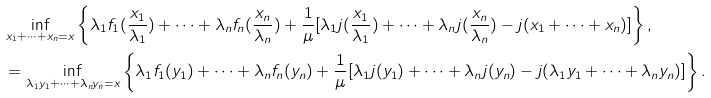Convert formula to latex. <formula><loc_0><loc_0><loc_500><loc_500>& \inf _ { x _ { 1 } + \cdots + x _ { n } = x } \left \{ \lambda _ { 1 } f _ { 1 } ( \frac { x _ { 1 } } { \lambda _ { 1 } } ) + \cdots + \lambda _ { n } f _ { n } ( \frac { x _ { n } } { \lambda _ { n } } ) + \frac { 1 } { \mu } [ \lambda _ { 1 } j ( \frac { x _ { 1 } } { \lambda _ { 1 } } ) + \cdots + \lambda _ { n } j ( \frac { x _ { n } } { \lambda _ { n } } ) - j ( x _ { 1 } + \cdots + x _ { n } ) ] \right \} , \\ & = \inf _ { \lambda _ { 1 } y _ { 1 } + \cdots + \lambda _ { n } y _ { n } = x } \left \{ \lambda _ { 1 } f _ { 1 } ( y _ { 1 } ) + \cdots + \lambda _ { n } f _ { n } ( y _ { n } ) + \frac { 1 } { \mu } [ \lambda _ { 1 } j ( y _ { 1 } ) + \cdots + \lambda _ { n } j ( y _ { n } ) - j ( \lambda _ { 1 } y _ { 1 } + \cdots + \lambda _ { n } y _ { n } ) ] \right \} .</formula> 